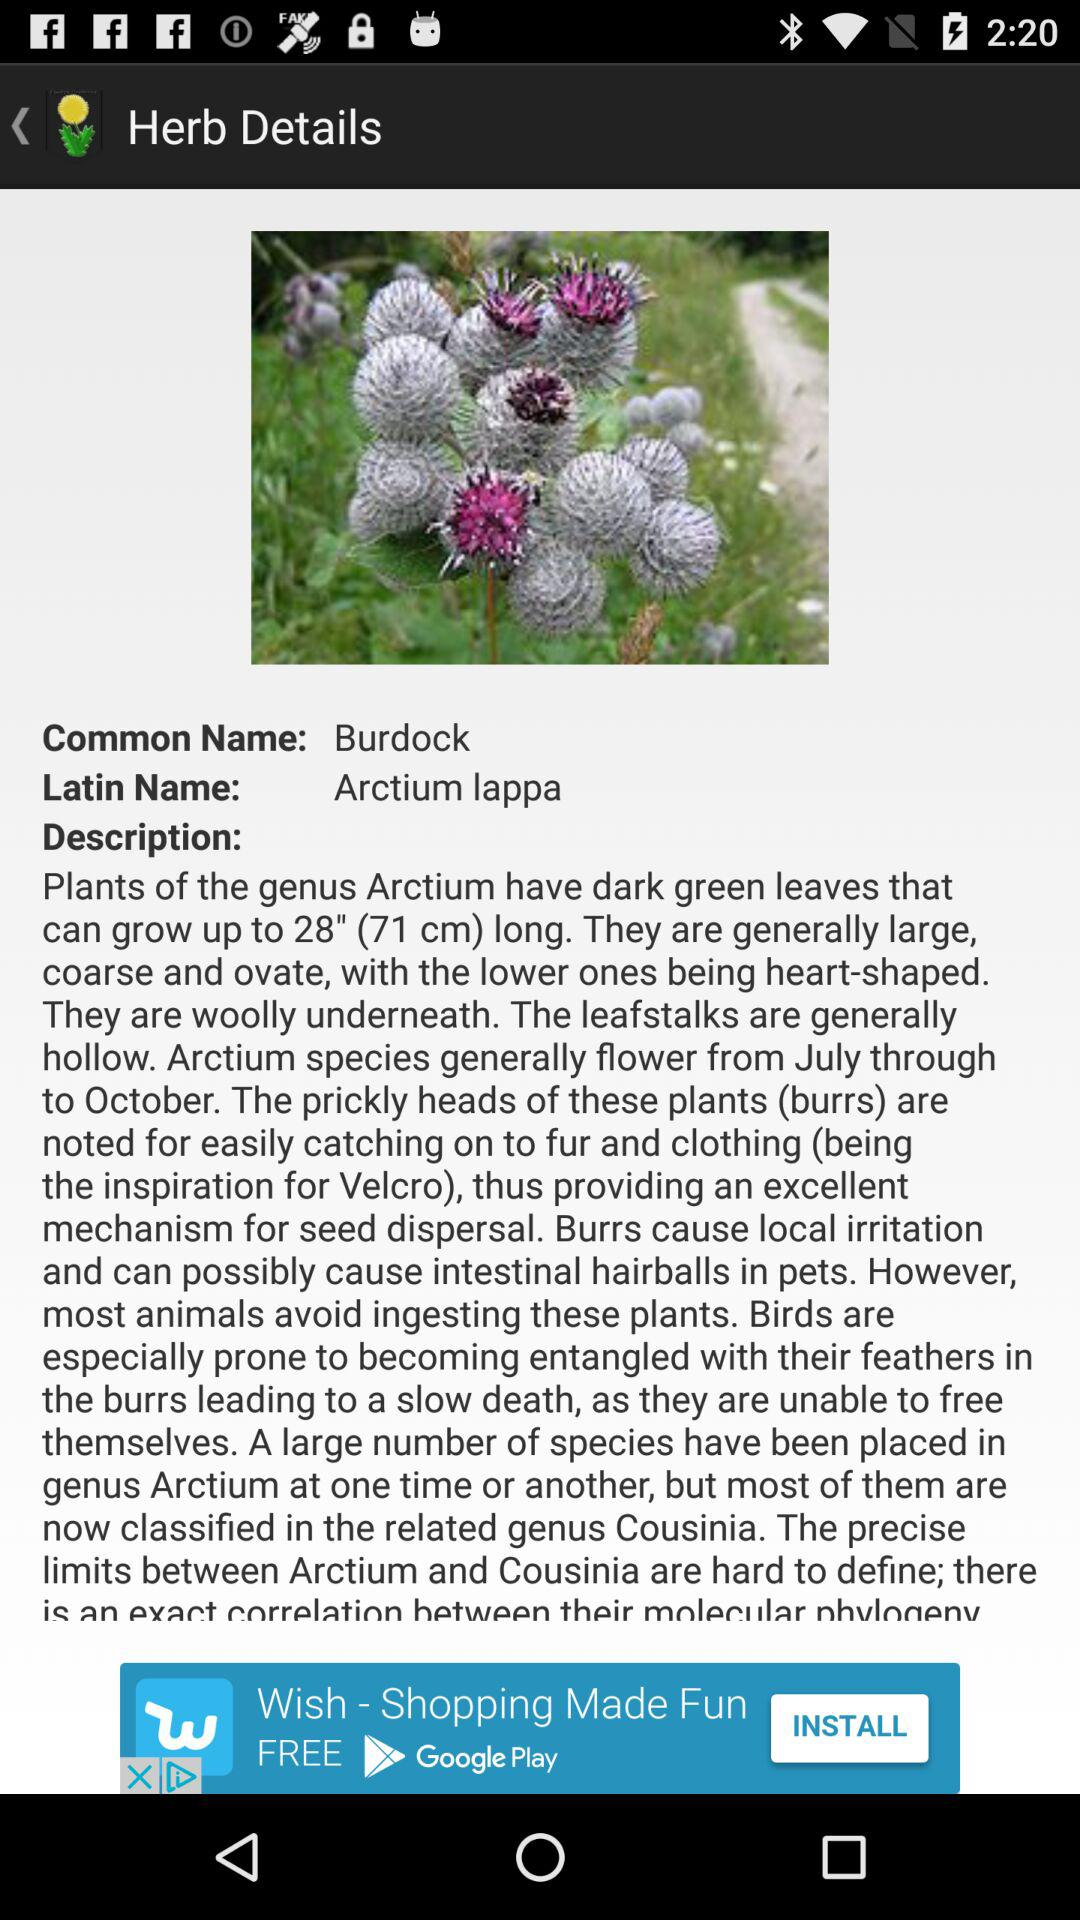What is the common name of the plant? The common name of the plant is "Burdock". 